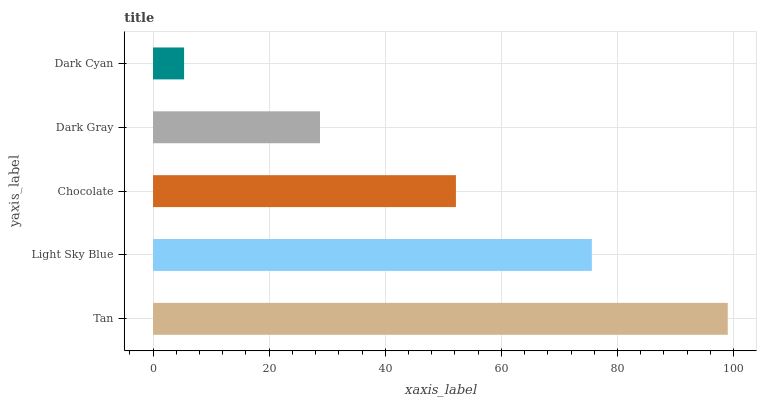Is Dark Cyan the minimum?
Answer yes or no. Yes. Is Tan the maximum?
Answer yes or no. Yes. Is Light Sky Blue the minimum?
Answer yes or no. No. Is Light Sky Blue the maximum?
Answer yes or no. No. Is Tan greater than Light Sky Blue?
Answer yes or no. Yes. Is Light Sky Blue less than Tan?
Answer yes or no. Yes. Is Light Sky Blue greater than Tan?
Answer yes or no. No. Is Tan less than Light Sky Blue?
Answer yes or no. No. Is Chocolate the high median?
Answer yes or no. Yes. Is Chocolate the low median?
Answer yes or no. Yes. Is Dark Cyan the high median?
Answer yes or no. No. Is Tan the low median?
Answer yes or no. No. 